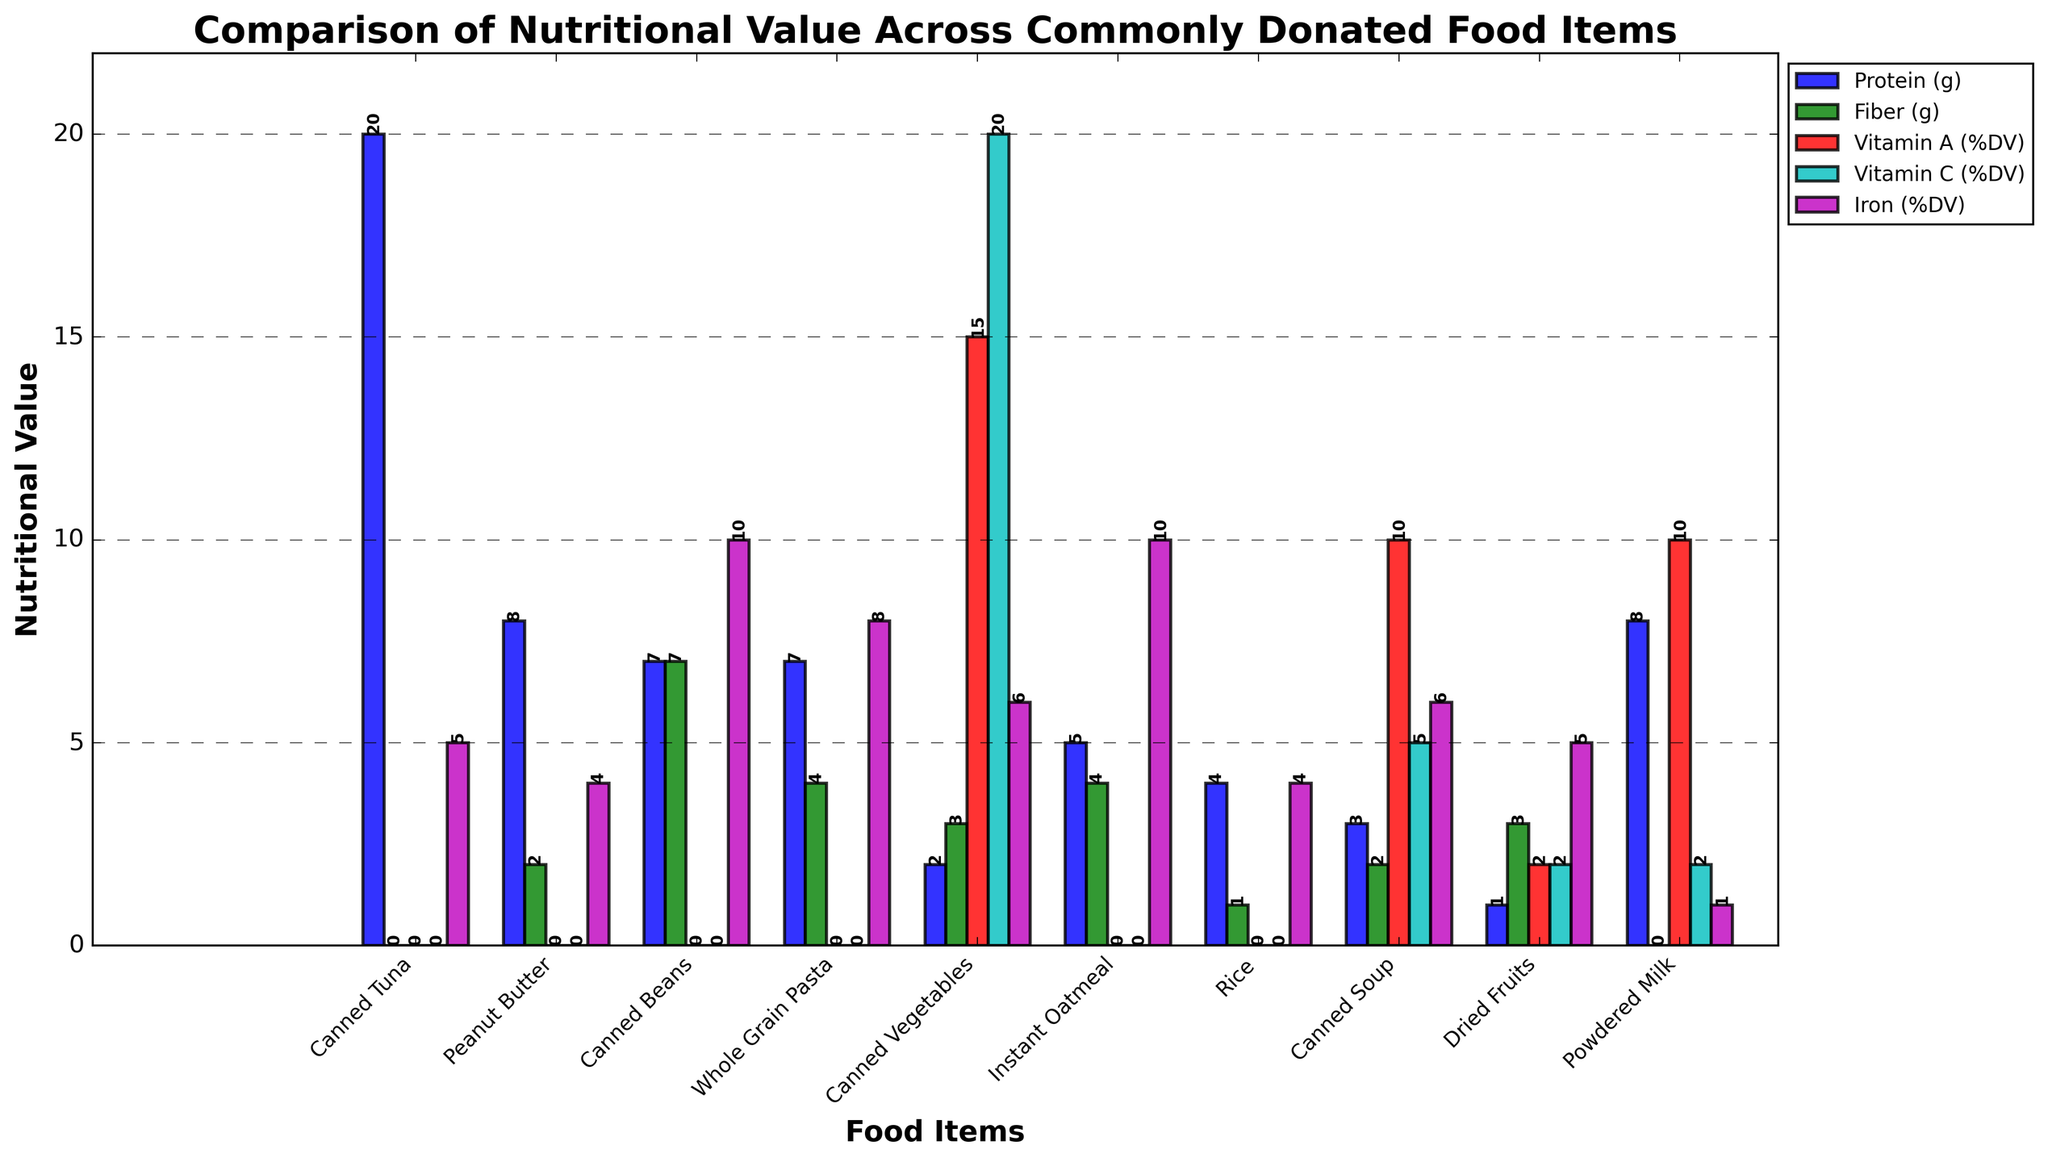Which food item has the highest protein content? By observing the protein bars in the figure, the tallest bar under the "Protein (g)" label belongs to Canned Tuna.
Answer: Canned Tuna Which food item has the lowest fiber content? By comparing the height of the bars under the "Fiber (g)" label, the smallest bar corresponds to the 0g fiber content of Canned Tuna and Powdered Milk.
Answer: Canned Tuna and Powdered Milk What is the average Iron (%DV) value for Peanut Butter, Instant Oatmeal, and Rice? Add the Iron (%DV) values of Peanut Butter (4), Instant Oatmeal (10), and Rice (4) to get 18, then divide by 3.
Answer: 6 Among the food items compared, which one offers the highest percentage of Vitamin A? By checking the Vitamin A (%DV) bars, the tallest bar corresponds to Canned Vegetables with 15%.
Answer: Canned Vegetables Compare the Vitamin C content between Canned Vegetables and Canned Soup. Which food item has a higher content? Compare the height of the Vitamin C (%DV) bars for these two foods. Canned Vegetables has a higher value (20%) compared to Canned Soup (5%).
Answer: Canned Vegetables What is the total amount of fiber in Whole Grain Pasta and Canned Beans combined? Sum the fiber content of Whole Grain Pasta (4g) and Canned Beans (7g) to get 11g.
Answer: 11g Which food item has equal values for both Vitamin A and Vitamin C percentages? By observing the Vitamin A and Vitamin C bars for all items, the equal percentages (10% each) are present for Canned Soup and Powdered Milk.
Answer: Canned Soup and Powdered Milk Identify a food item with an Iron (%DV) content of 6%. By locating the iron bars, the food items that align with the 6% bar are Canned Vegetables and Canned Soup.
Answer: Canned Vegetables and Canned Soup How much more protein does Canned Tuna have compared to Rice? Subtract the protein in Rice (4g) from the protein in Canned Tuna (20g), resulting in 16g more protein in Canned Tuna.
Answer: 16g Which nutrient do Instant Oatmeal and Whole Grain Pasta have the same value? By comparing bars, the fiber content for Instant Oatmeal (4g) and Whole Grain Pasta (4g) is equal.
Answer: Fiber 